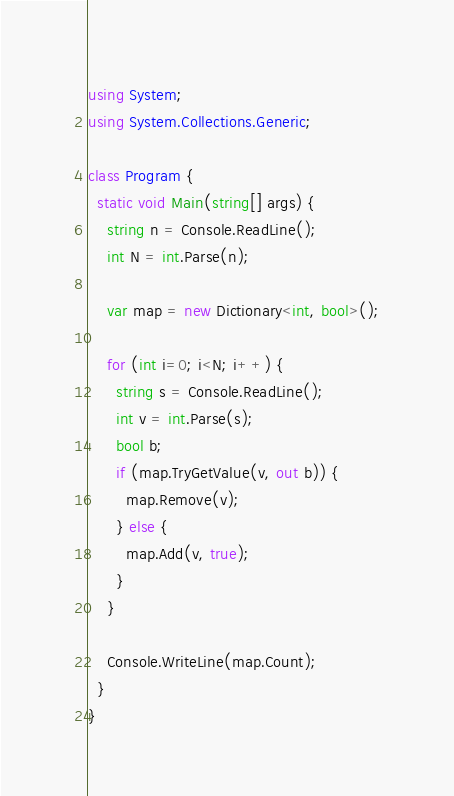Convert code to text. <code><loc_0><loc_0><loc_500><loc_500><_C#_>using System;
using System.Collections.Generic;

class Program {
  static void Main(string[] args) {
    string n = Console.ReadLine();
    int N = int.Parse(n);

    var map = new Dictionary<int, bool>();
    
    for (int i=0; i<N; i++) {
      string s = Console.ReadLine();
      int v = int.Parse(s);
      bool b;
      if (map.TryGetValue(v, out b)) {
        map.Remove(v);
      } else {
        map.Add(v, true);
      }
    }

    Console.WriteLine(map.Count);
  }
}</code> 